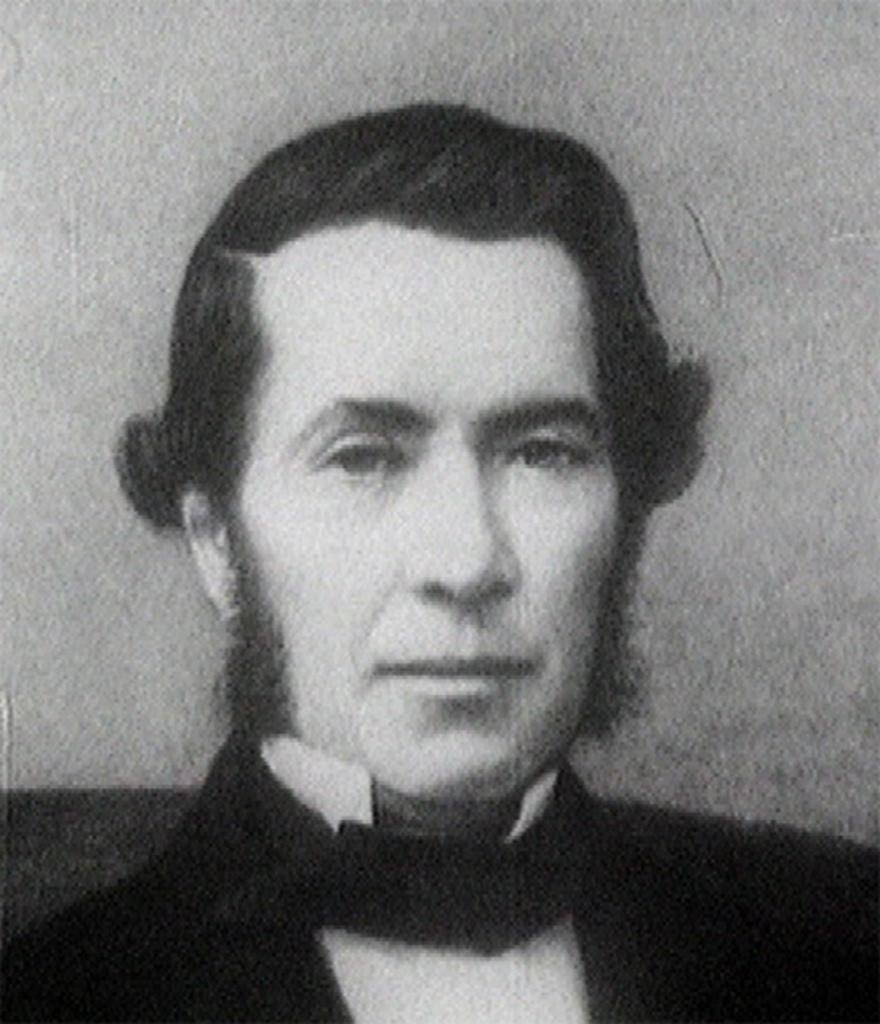What is the main subject of the image? The main subject of the image is a person. Can you describe the person in the drawing? Unfortunately, the provided facts do not include any details about the person's appearance or characteristics. What type of plants can be seen growing around the person in the image? There are no plants visible in the image; it is a drawing of a person. Can you describe the rat that is interacting with the person in the image? There is no rat present in the image; it is a drawing of a person. 